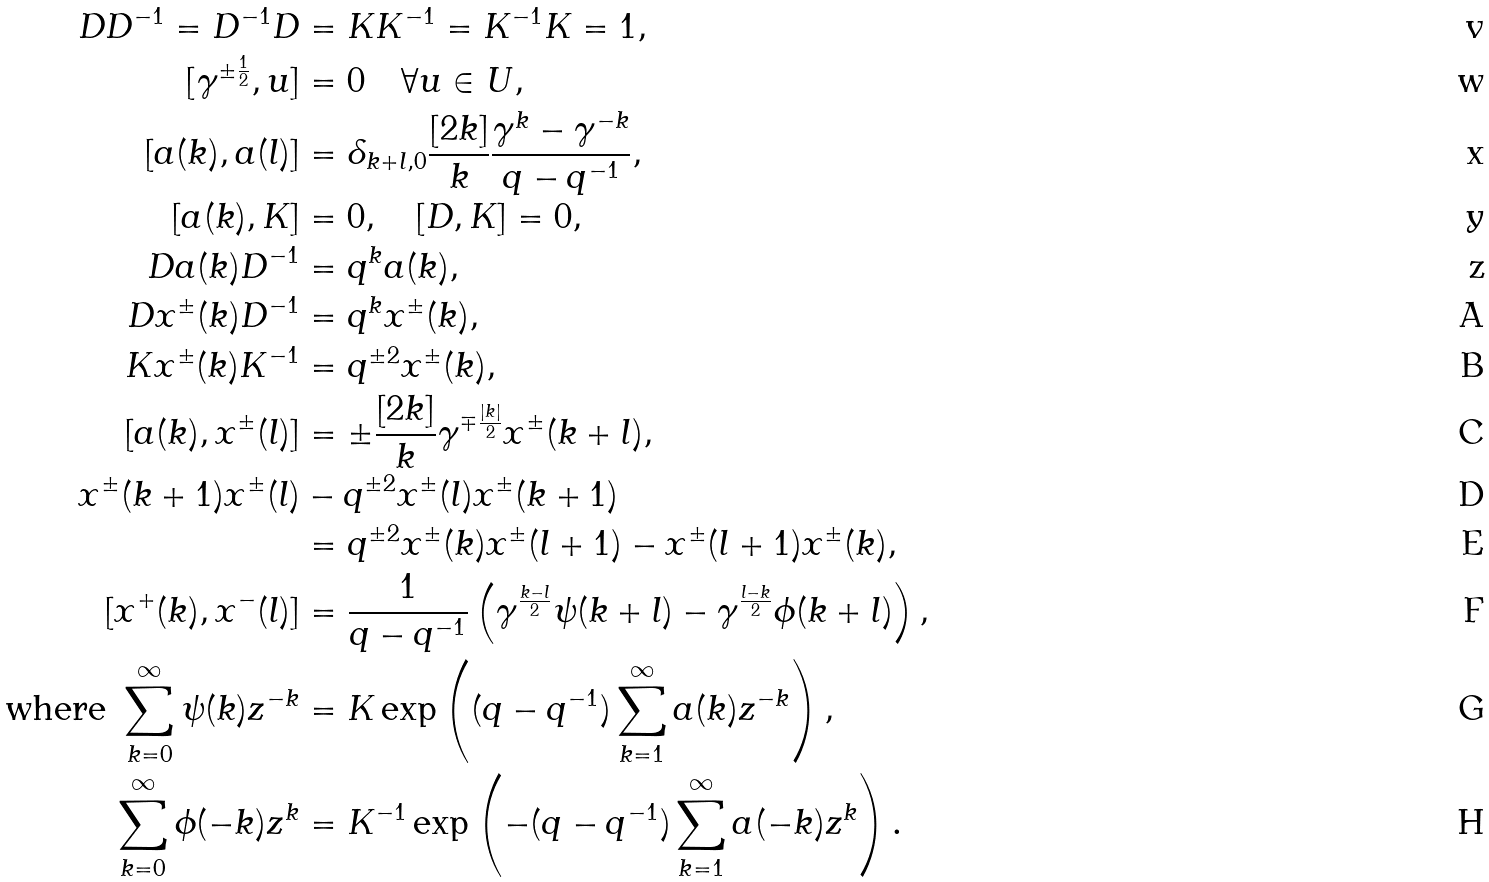<formula> <loc_0><loc_0><loc_500><loc_500>D D ^ { - 1 } = D ^ { - 1 } D & = K K ^ { - 1 } = K ^ { - 1 } K = 1 , \\ [ \gamma ^ { \pm \frac { 1 } { 2 } } , u ] & = 0 \quad \forall u \in U , \\ [ a ( k ) , a ( l ) ] & = \delta _ { k + l , 0 } \frac { [ 2 k ] } { k } \frac { \gamma ^ { k } - \gamma ^ { - k } } { q - q ^ { - 1 } } , \\ [ a ( k ) , K ] & = 0 , \quad [ D , K ] = 0 , \\ D a ( k ) D ^ { - 1 } & = q ^ { k } a ( k ) , \\ D x ^ { \pm } ( k ) D ^ { - 1 } & = q ^ { k } x ^ { \pm } ( k ) , \\ K x ^ { \pm } ( k ) K ^ { - 1 } & = q ^ { \pm 2 } x ^ { \pm } ( k ) , \\ [ a ( k ) , x ^ { \pm } ( l ) ] & = \pm \frac { [ 2 k ] } { k } \gamma ^ { \mp \frac { | k | } { 2 } } x ^ { \pm } ( k + l ) , \\ x ^ { \pm } ( k + 1 ) x ^ { \pm } ( l ) & - q ^ { \pm 2 } x ^ { \pm } ( l ) x ^ { \pm } ( k + 1 ) \\ & = q ^ { \pm 2 } x ^ { \pm } ( k ) x ^ { \pm } ( l + 1 ) - x ^ { \pm } ( l + 1 ) x ^ { \pm } ( k ) , \\ [ x ^ { + } ( k ) , x ^ { - } ( l ) ] & = \frac { 1 } { q - q ^ { - 1 } } \left ( \gamma ^ { \frac { k - l } { 2 } } \psi ( k + l ) - \gamma ^ { \frac { l - k } { 2 } } \phi ( k + l ) \right ) , \\ \text {where } \sum _ { k = 0 } ^ { \infty } \psi ( k ) z ^ { - k } & = K \exp \left ( ( q - q ^ { - 1 } ) \sum _ { k = 1 } ^ { \infty } a ( k ) z ^ { - k } \right ) , \\ \sum _ { k = 0 } ^ { \infty } \phi ( - k ) z ^ { k } & = K ^ { - 1 } \exp \left ( - ( q - q ^ { - 1 } ) \sum _ { k = 1 } ^ { \infty } a ( - k ) z ^ { k } \right ) .</formula> 